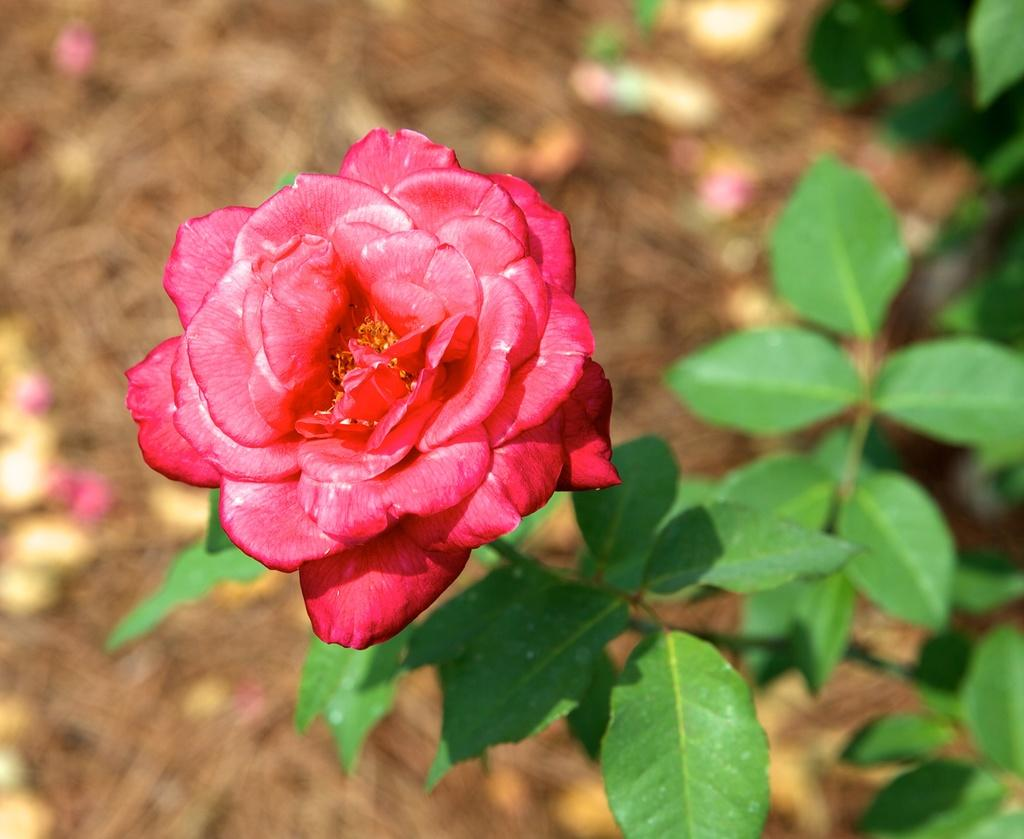What type of plant is featured in the image? There is a plant with a red rose in the image. Are there any other plants visible in the image? Yes, there are other plants in the image. What can be seen in the background of the image? There are objects in the background of the image. How would you describe the background of the image? The background of the image is blurred. What type of cracker is being used to stir the fire in the image? There is no cracker or fire present in the image; it features a plant with a red rose and other plants. 